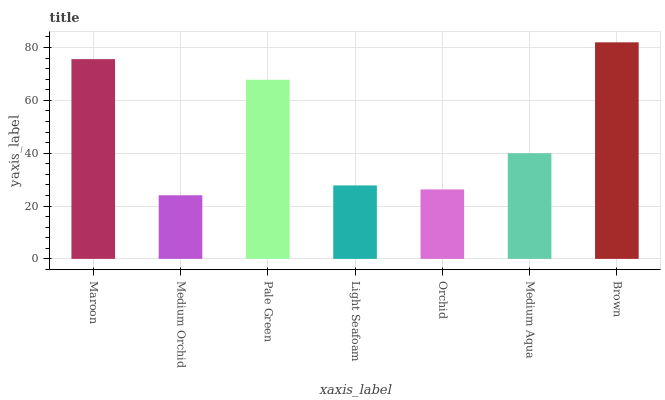Is Pale Green the minimum?
Answer yes or no. No. Is Pale Green the maximum?
Answer yes or no. No. Is Pale Green greater than Medium Orchid?
Answer yes or no. Yes. Is Medium Orchid less than Pale Green?
Answer yes or no. Yes. Is Medium Orchid greater than Pale Green?
Answer yes or no. No. Is Pale Green less than Medium Orchid?
Answer yes or no. No. Is Medium Aqua the high median?
Answer yes or no. Yes. Is Medium Aqua the low median?
Answer yes or no. Yes. Is Pale Green the high median?
Answer yes or no. No. Is Orchid the low median?
Answer yes or no. No. 